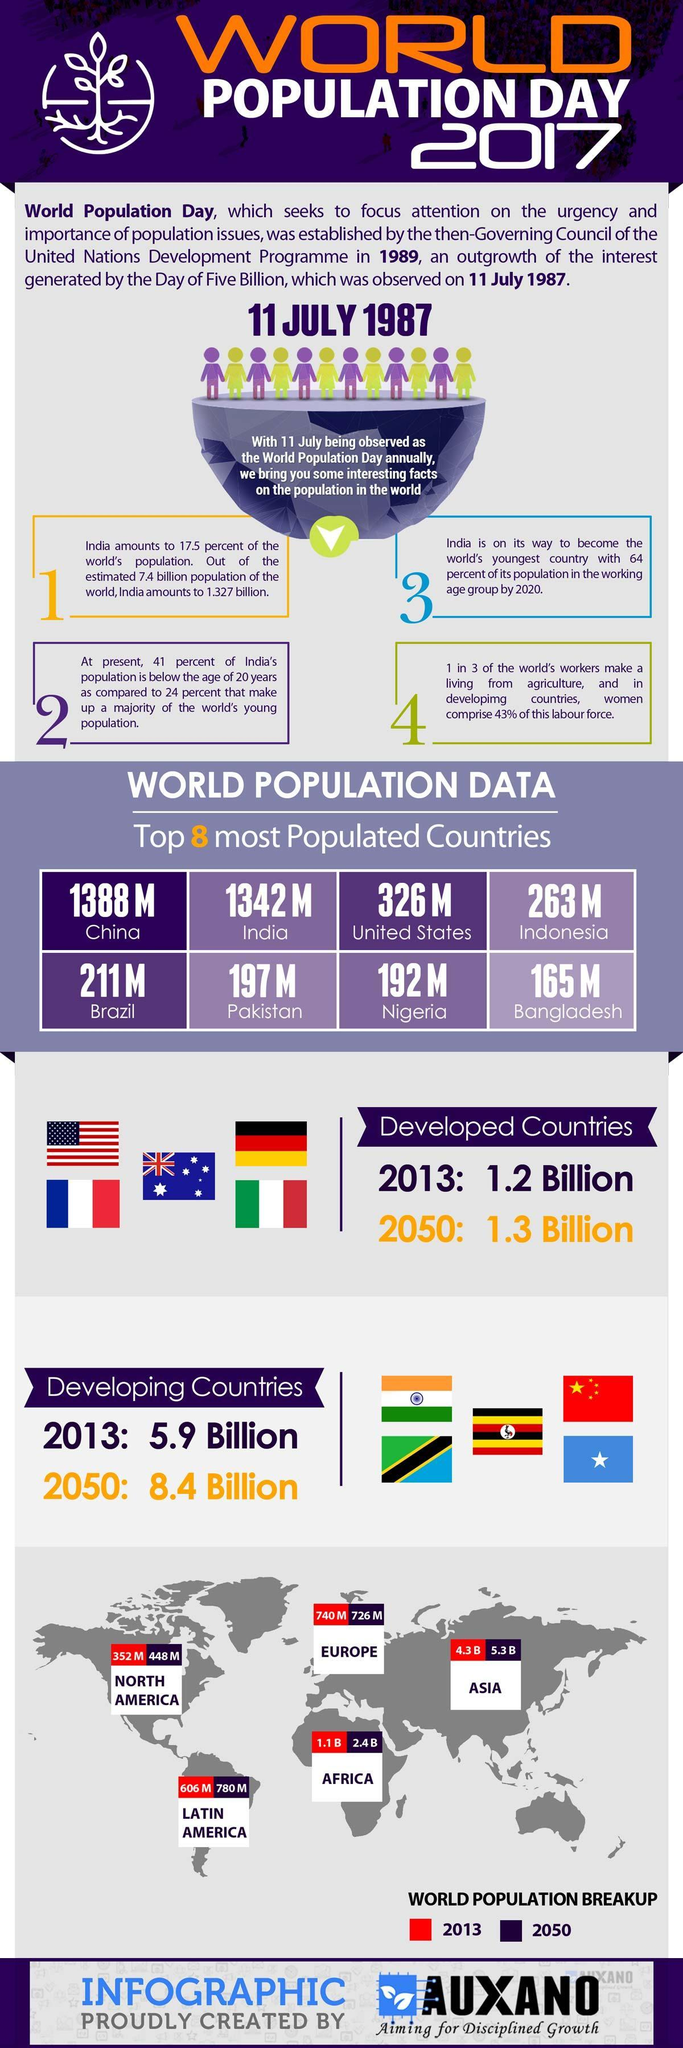How many developing countries' flags mentioned in this infographic?
Answer the question with a short phrase. 5 How many developed countries' flags mentioned in this infographic? 5 